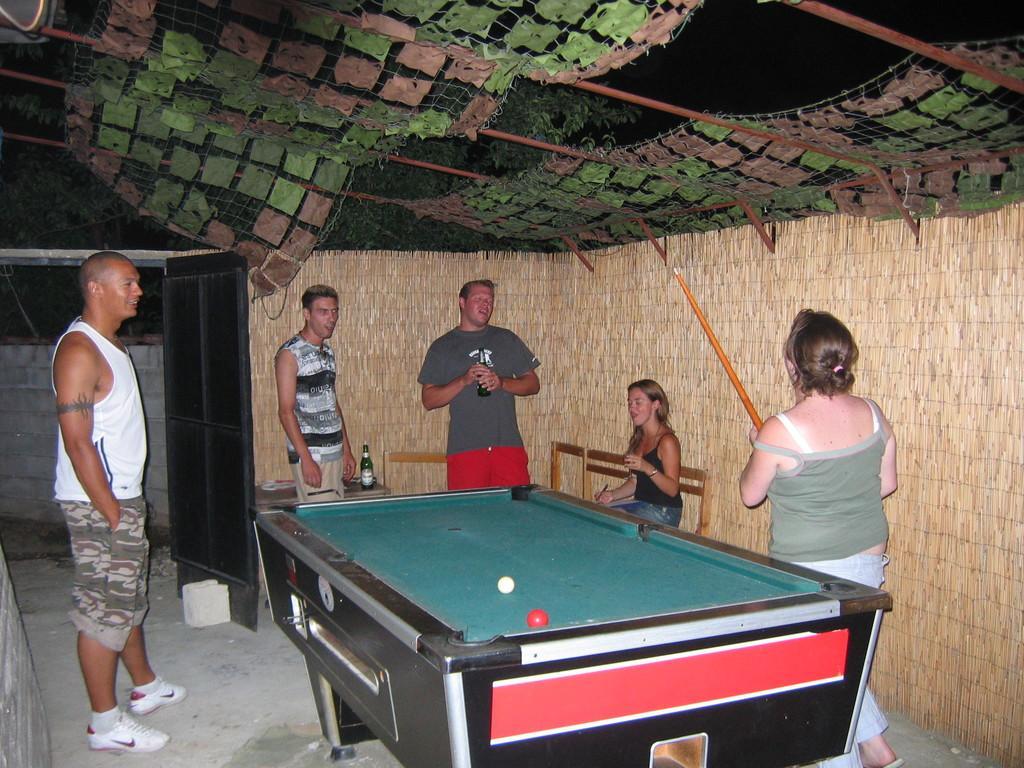Can you describe this image briefly? The women in the right is holding a snooker stick and there is a snooker table beside her and there are group of people standing in front of her. 